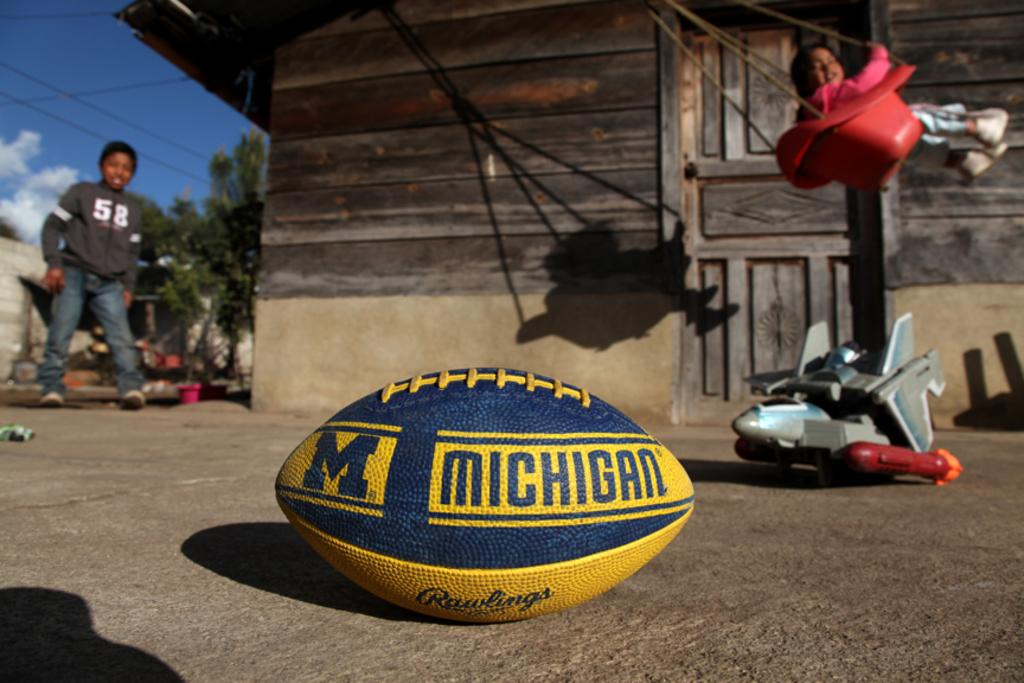What object is on the ground in the image? There is a ball and a toy on the ground in the image. Where is the boy located in the image? The boy is on the left side of the image. What is the girl doing in the image? The girl is swinging in the image. What can be seen in the background of the image? There are buildings and trees in the background of the image. What is the weather like in the image? The sky is cloudy in the image. What type of horse is the boy riding in the image? There is no horse present in the image; the boy is standing on the left side. What hobbies does the girl have, as indicated by the image? The image does not provide information about the girl's hobbies. What design elements can be seen in the buildings in the background? The image does not provide enough detail to describe the design elements of the buildings in the background. 